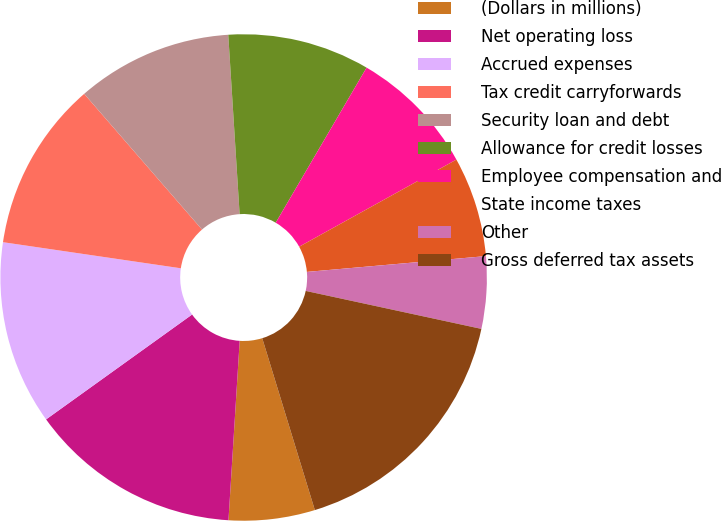<chart> <loc_0><loc_0><loc_500><loc_500><pie_chart><fcel>(Dollars in millions)<fcel>Net operating loss<fcel>Accrued expenses<fcel>Tax credit carryforwards<fcel>Security loan and debt<fcel>Allowance for credit losses<fcel>Employee compensation and<fcel>State income taxes<fcel>Other<fcel>Gross deferred tax assets<nl><fcel>5.72%<fcel>14.09%<fcel>12.23%<fcel>11.3%<fcel>10.37%<fcel>9.44%<fcel>8.51%<fcel>6.65%<fcel>4.79%<fcel>16.88%<nl></chart> 